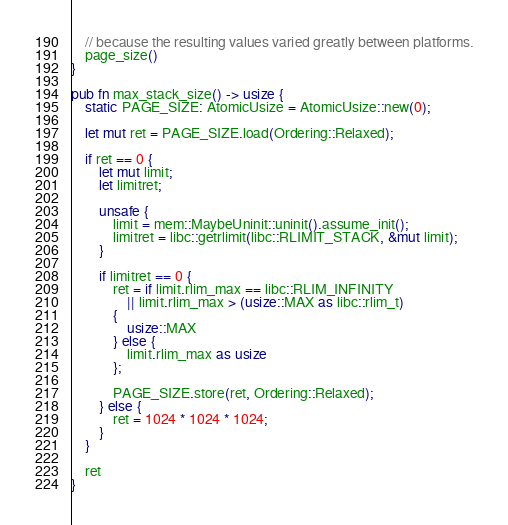<code> <loc_0><loc_0><loc_500><loc_500><_Rust_>    // because the resulting values varied greatly between platforms.
    page_size()
}

pub fn max_stack_size() -> usize {
    static PAGE_SIZE: AtomicUsize = AtomicUsize::new(0);

    let mut ret = PAGE_SIZE.load(Ordering::Relaxed);

    if ret == 0 {
        let mut limit;
        let limitret;

        unsafe {
            limit = mem::MaybeUninit::uninit().assume_init();
            limitret = libc::getrlimit(libc::RLIMIT_STACK, &mut limit);
        }

        if limitret == 0 {
            ret = if limit.rlim_max == libc::RLIM_INFINITY
                || limit.rlim_max > (usize::MAX as libc::rlim_t)
            {
                usize::MAX
            } else {
                limit.rlim_max as usize
            };

            PAGE_SIZE.store(ret, Ordering::Relaxed);
        } else {
            ret = 1024 * 1024 * 1024;
        }
    }

    ret
}
</code> 